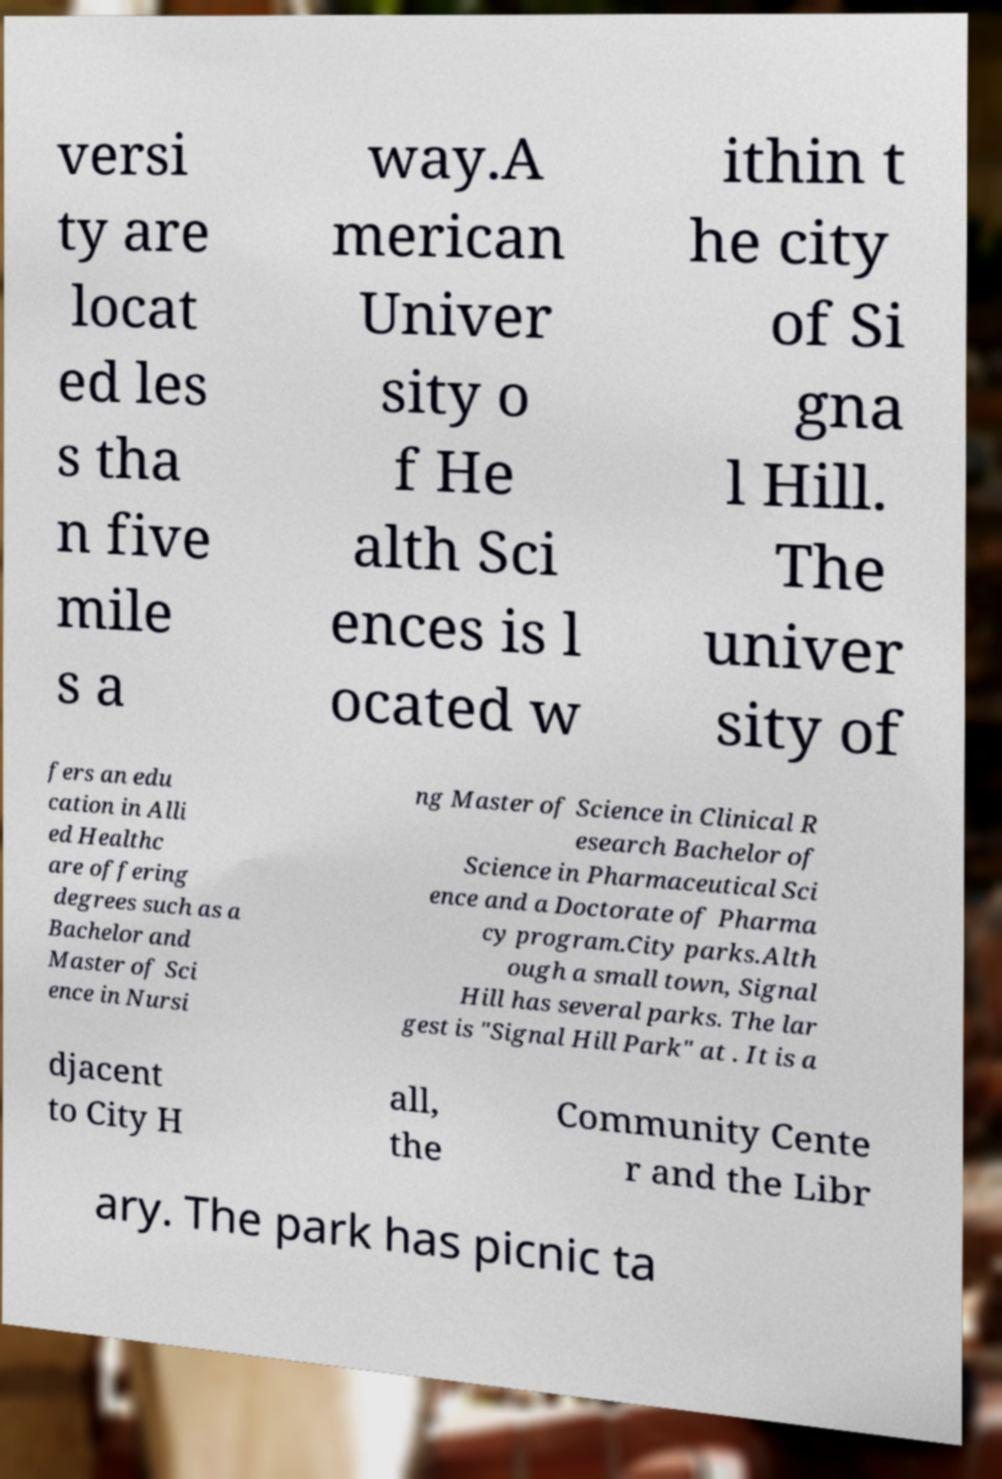What messages or text are displayed in this image? I need them in a readable, typed format. versi ty are locat ed les s tha n five mile s a way.A merican Univer sity o f He alth Sci ences is l ocated w ithin t he city of Si gna l Hill. The univer sity of fers an edu cation in Alli ed Healthc are offering degrees such as a Bachelor and Master of Sci ence in Nursi ng Master of Science in Clinical R esearch Bachelor of Science in Pharmaceutical Sci ence and a Doctorate of Pharma cy program.City parks.Alth ough a small town, Signal Hill has several parks. The lar gest is "Signal Hill Park" at . It is a djacent to City H all, the Community Cente r and the Libr ary. The park has picnic ta 